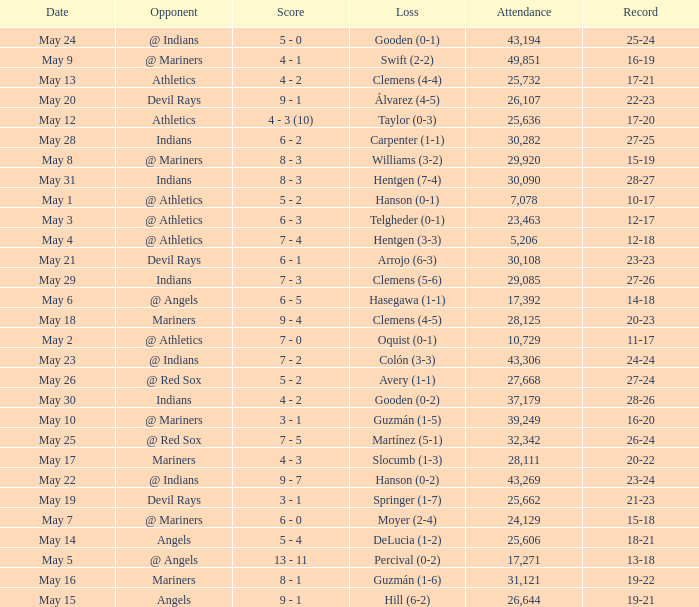Who lost on May 31? Hentgen (7-4). 